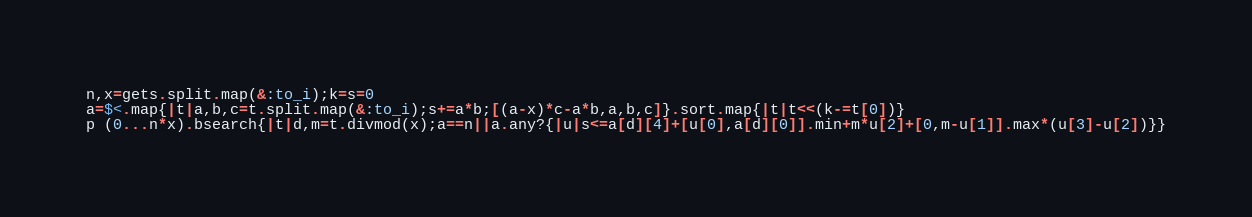Convert code to text. <code><loc_0><loc_0><loc_500><loc_500><_Ruby_>n,x=gets.split.map(&:to_i);k=s=0
a=$<.map{|t|a,b,c=t.split.map(&:to_i);s+=a*b;[(a-x)*c-a*b,a,b,c]}.sort.map{|t|t<<(k-=t[0])}
p (0...n*x).bsearch{|t|d,m=t.divmod(x);a==n||a.any?{|u|s<=a[d][4]+[u[0],a[d][0]].min+m*u[2]+[0,m-u[1]].max*(u[3]-u[2])}}</code> 